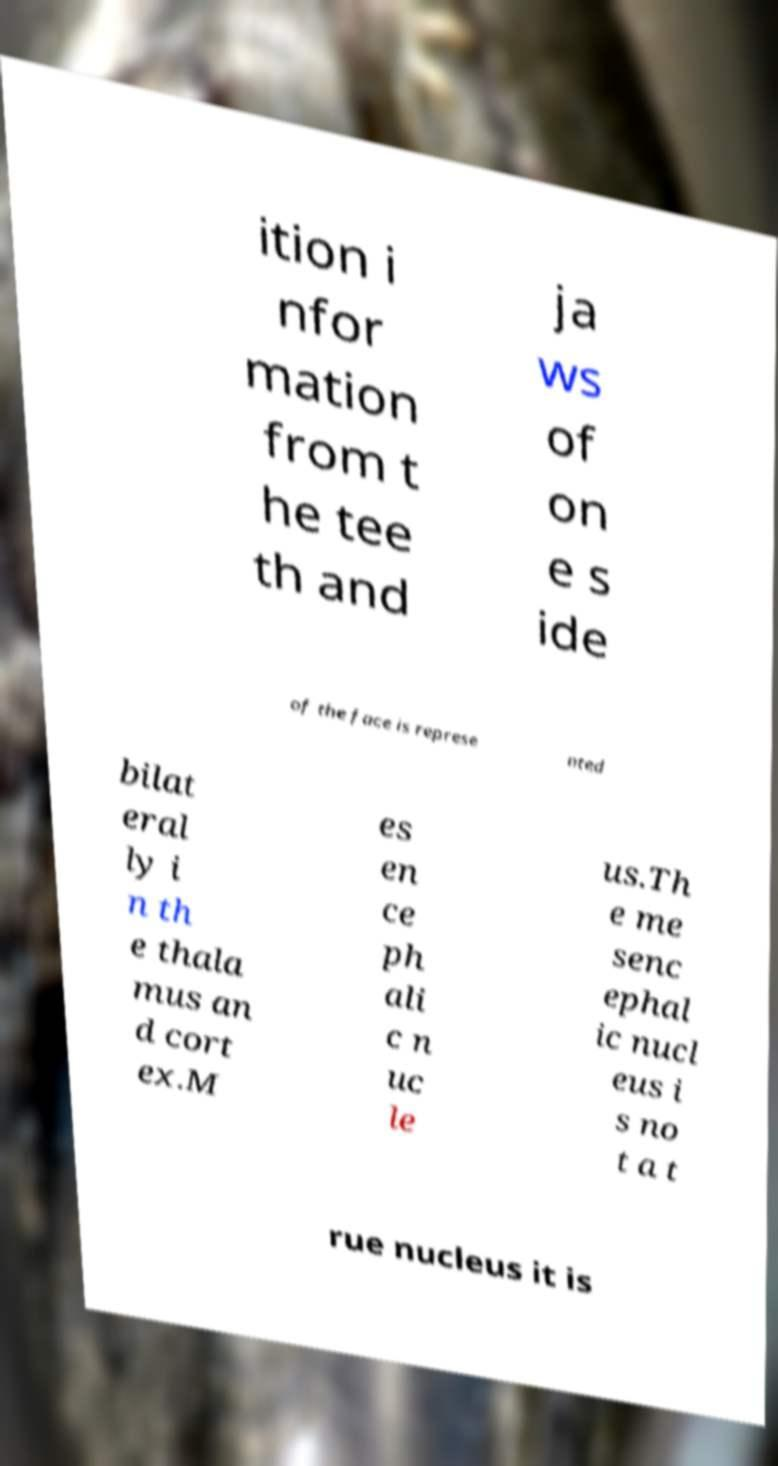For documentation purposes, I need the text within this image transcribed. Could you provide that? ition i nfor mation from t he tee th and ja ws of on e s ide of the face is represe nted bilat eral ly i n th e thala mus an d cort ex.M es en ce ph ali c n uc le us.Th e me senc ephal ic nucl eus i s no t a t rue nucleus it is 